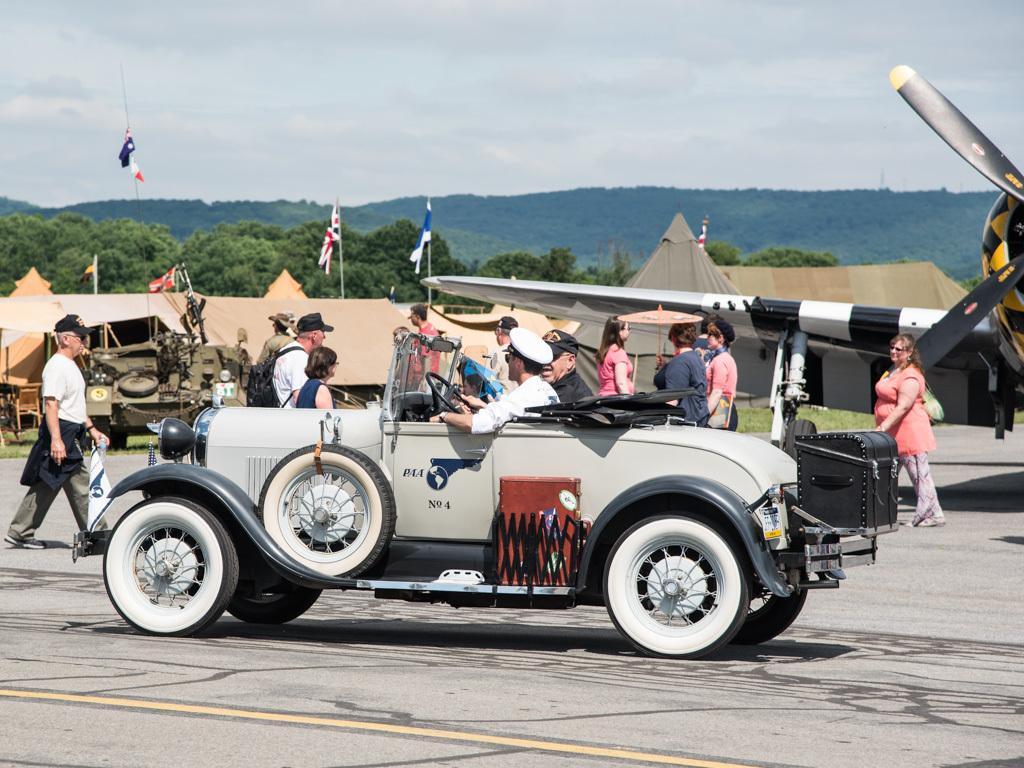Can you describe this image briefly? As we can see in the image there is a car, few people here and there, houses, flags, trees and sky. 